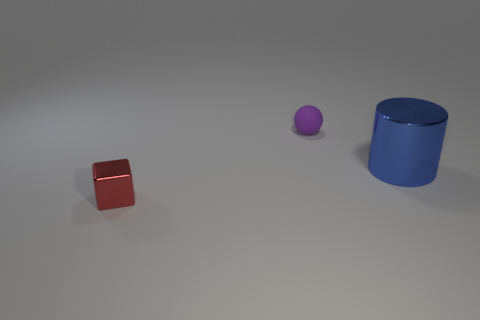Subtract all balls. How many objects are left? 2 Add 2 yellow matte cubes. How many objects exist? 5 Add 3 green metallic blocks. How many green metallic blocks exist? 3 Subtract 0 gray cylinders. How many objects are left? 3 Subtract all cyan blocks. How many green spheres are left? 0 Subtract all gray shiny cylinders. Subtract all large metallic objects. How many objects are left? 2 Add 3 tiny purple rubber objects. How many tiny purple rubber objects are left? 4 